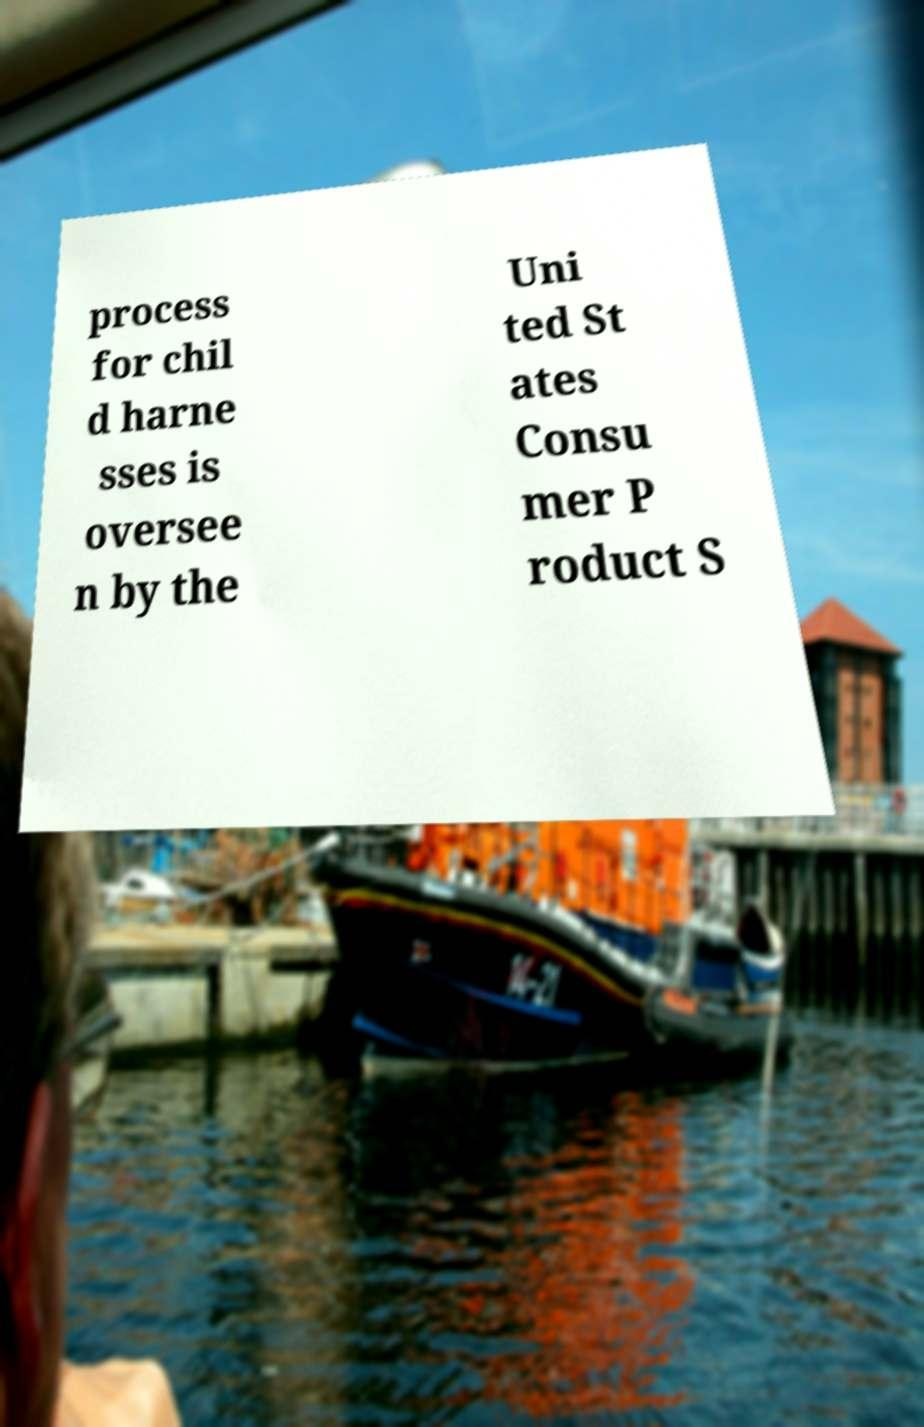Could you extract and type out the text from this image? process for chil d harne sses is oversee n by the Uni ted St ates Consu mer P roduct S 